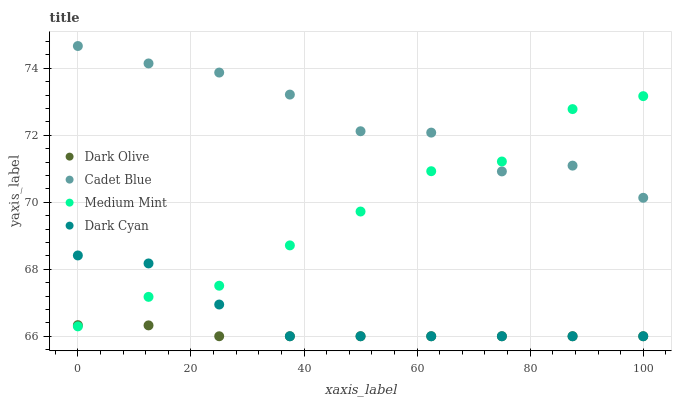Does Dark Olive have the minimum area under the curve?
Answer yes or no. Yes. Does Cadet Blue have the maximum area under the curve?
Answer yes or no. Yes. Does Medium Mint have the minimum area under the curve?
Answer yes or no. No. Does Medium Mint have the maximum area under the curve?
Answer yes or no. No. Is Dark Olive the smoothest?
Answer yes or no. Yes. Is Cadet Blue the roughest?
Answer yes or no. Yes. Is Medium Mint the smoothest?
Answer yes or no. No. Is Medium Mint the roughest?
Answer yes or no. No. Does Dark Olive have the lowest value?
Answer yes or no. Yes. Does Medium Mint have the lowest value?
Answer yes or no. No. Does Cadet Blue have the highest value?
Answer yes or no. Yes. Does Medium Mint have the highest value?
Answer yes or no. No. Is Dark Olive less than Cadet Blue?
Answer yes or no. Yes. Is Cadet Blue greater than Dark Olive?
Answer yes or no. Yes. Does Cadet Blue intersect Medium Mint?
Answer yes or no. Yes. Is Cadet Blue less than Medium Mint?
Answer yes or no. No. Is Cadet Blue greater than Medium Mint?
Answer yes or no. No. Does Dark Olive intersect Cadet Blue?
Answer yes or no. No. 